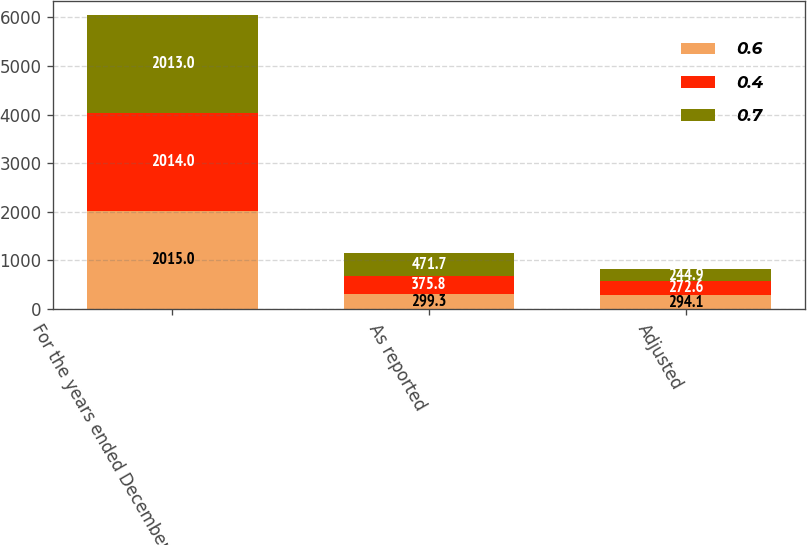<chart> <loc_0><loc_0><loc_500><loc_500><stacked_bar_chart><ecel><fcel>For the years ended December<fcel>As reported<fcel>Adjusted<nl><fcel>0.6<fcel>2015<fcel>299.3<fcel>294.1<nl><fcel>0.4<fcel>2014<fcel>375.8<fcel>272.6<nl><fcel>0.7<fcel>2013<fcel>471.7<fcel>244.9<nl></chart> 